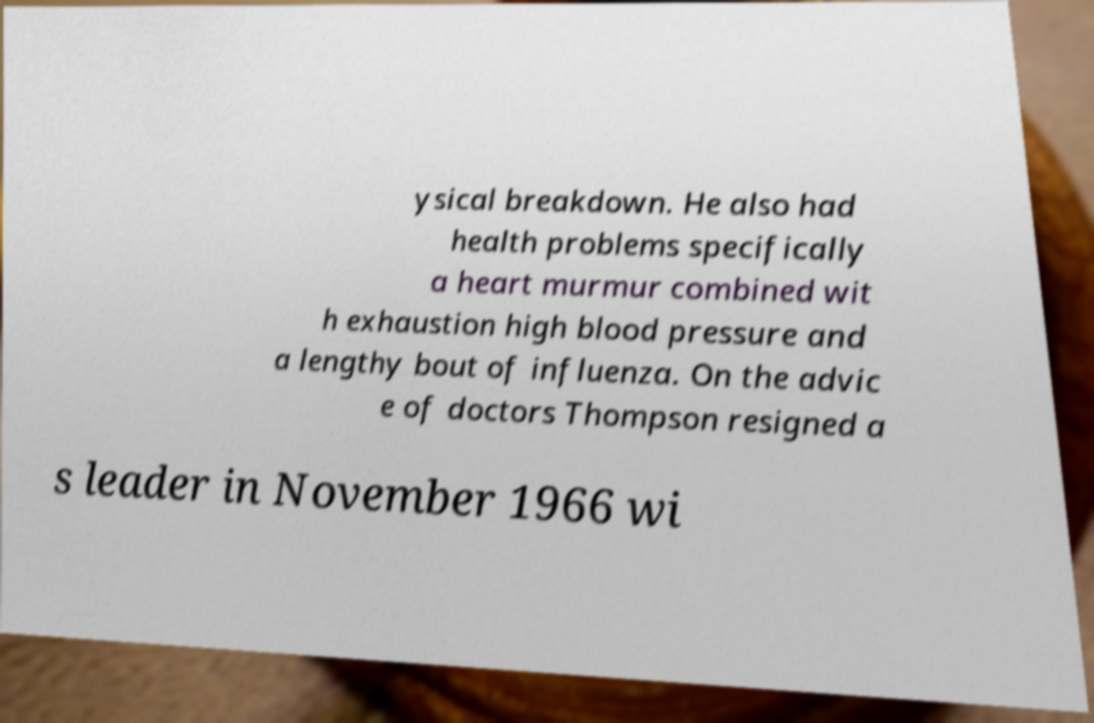Can you accurately transcribe the text from the provided image for me? ysical breakdown. He also had health problems specifically a heart murmur combined wit h exhaustion high blood pressure and a lengthy bout of influenza. On the advic e of doctors Thompson resigned a s leader in November 1966 wi 